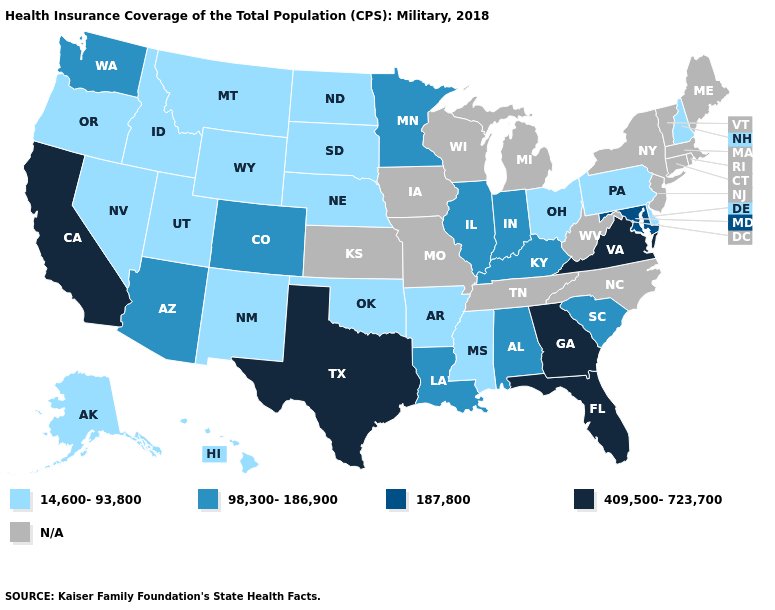What is the value of Alaska?
Be succinct. 14,600-93,800. What is the value of New York?
Be succinct. N/A. Name the states that have a value in the range 98,300-186,900?
Give a very brief answer. Alabama, Arizona, Colorado, Illinois, Indiana, Kentucky, Louisiana, Minnesota, South Carolina, Washington. Does Arkansas have the lowest value in the South?
Give a very brief answer. Yes. What is the value of North Carolina?
Be succinct. N/A. Does Arkansas have the lowest value in the USA?
Short answer required. Yes. What is the highest value in states that border North Carolina?
Quick response, please. 409,500-723,700. Among the states that border Tennessee , which have the highest value?
Give a very brief answer. Georgia, Virginia. What is the lowest value in the South?
Give a very brief answer. 14,600-93,800. Which states have the lowest value in the Northeast?
Quick response, please. New Hampshire, Pennsylvania. Name the states that have a value in the range 14,600-93,800?
Be succinct. Alaska, Arkansas, Delaware, Hawaii, Idaho, Mississippi, Montana, Nebraska, Nevada, New Hampshire, New Mexico, North Dakota, Ohio, Oklahoma, Oregon, Pennsylvania, South Dakota, Utah, Wyoming. Name the states that have a value in the range 14,600-93,800?
Write a very short answer. Alaska, Arkansas, Delaware, Hawaii, Idaho, Mississippi, Montana, Nebraska, Nevada, New Hampshire, New Mexico, North Dakota, Ohio, Oklahoma, Oregon, Pennsylvania, South Dakota, Utah, Wyoming. Name the states that have a value in the range 409,500-723,700?
Be succinct. California, Florida, Georgia, Texas, Virginia. Name the states that have a value in the range N/A?
Quick response, please. Connecticut, Iowa, Kansas, Maine, Massachusetts, Michigan, Missouri, New Jersey, New York, North Carolina, Rhode Island, Tennessee, Vermont, West Virginia, Wisconsin. 